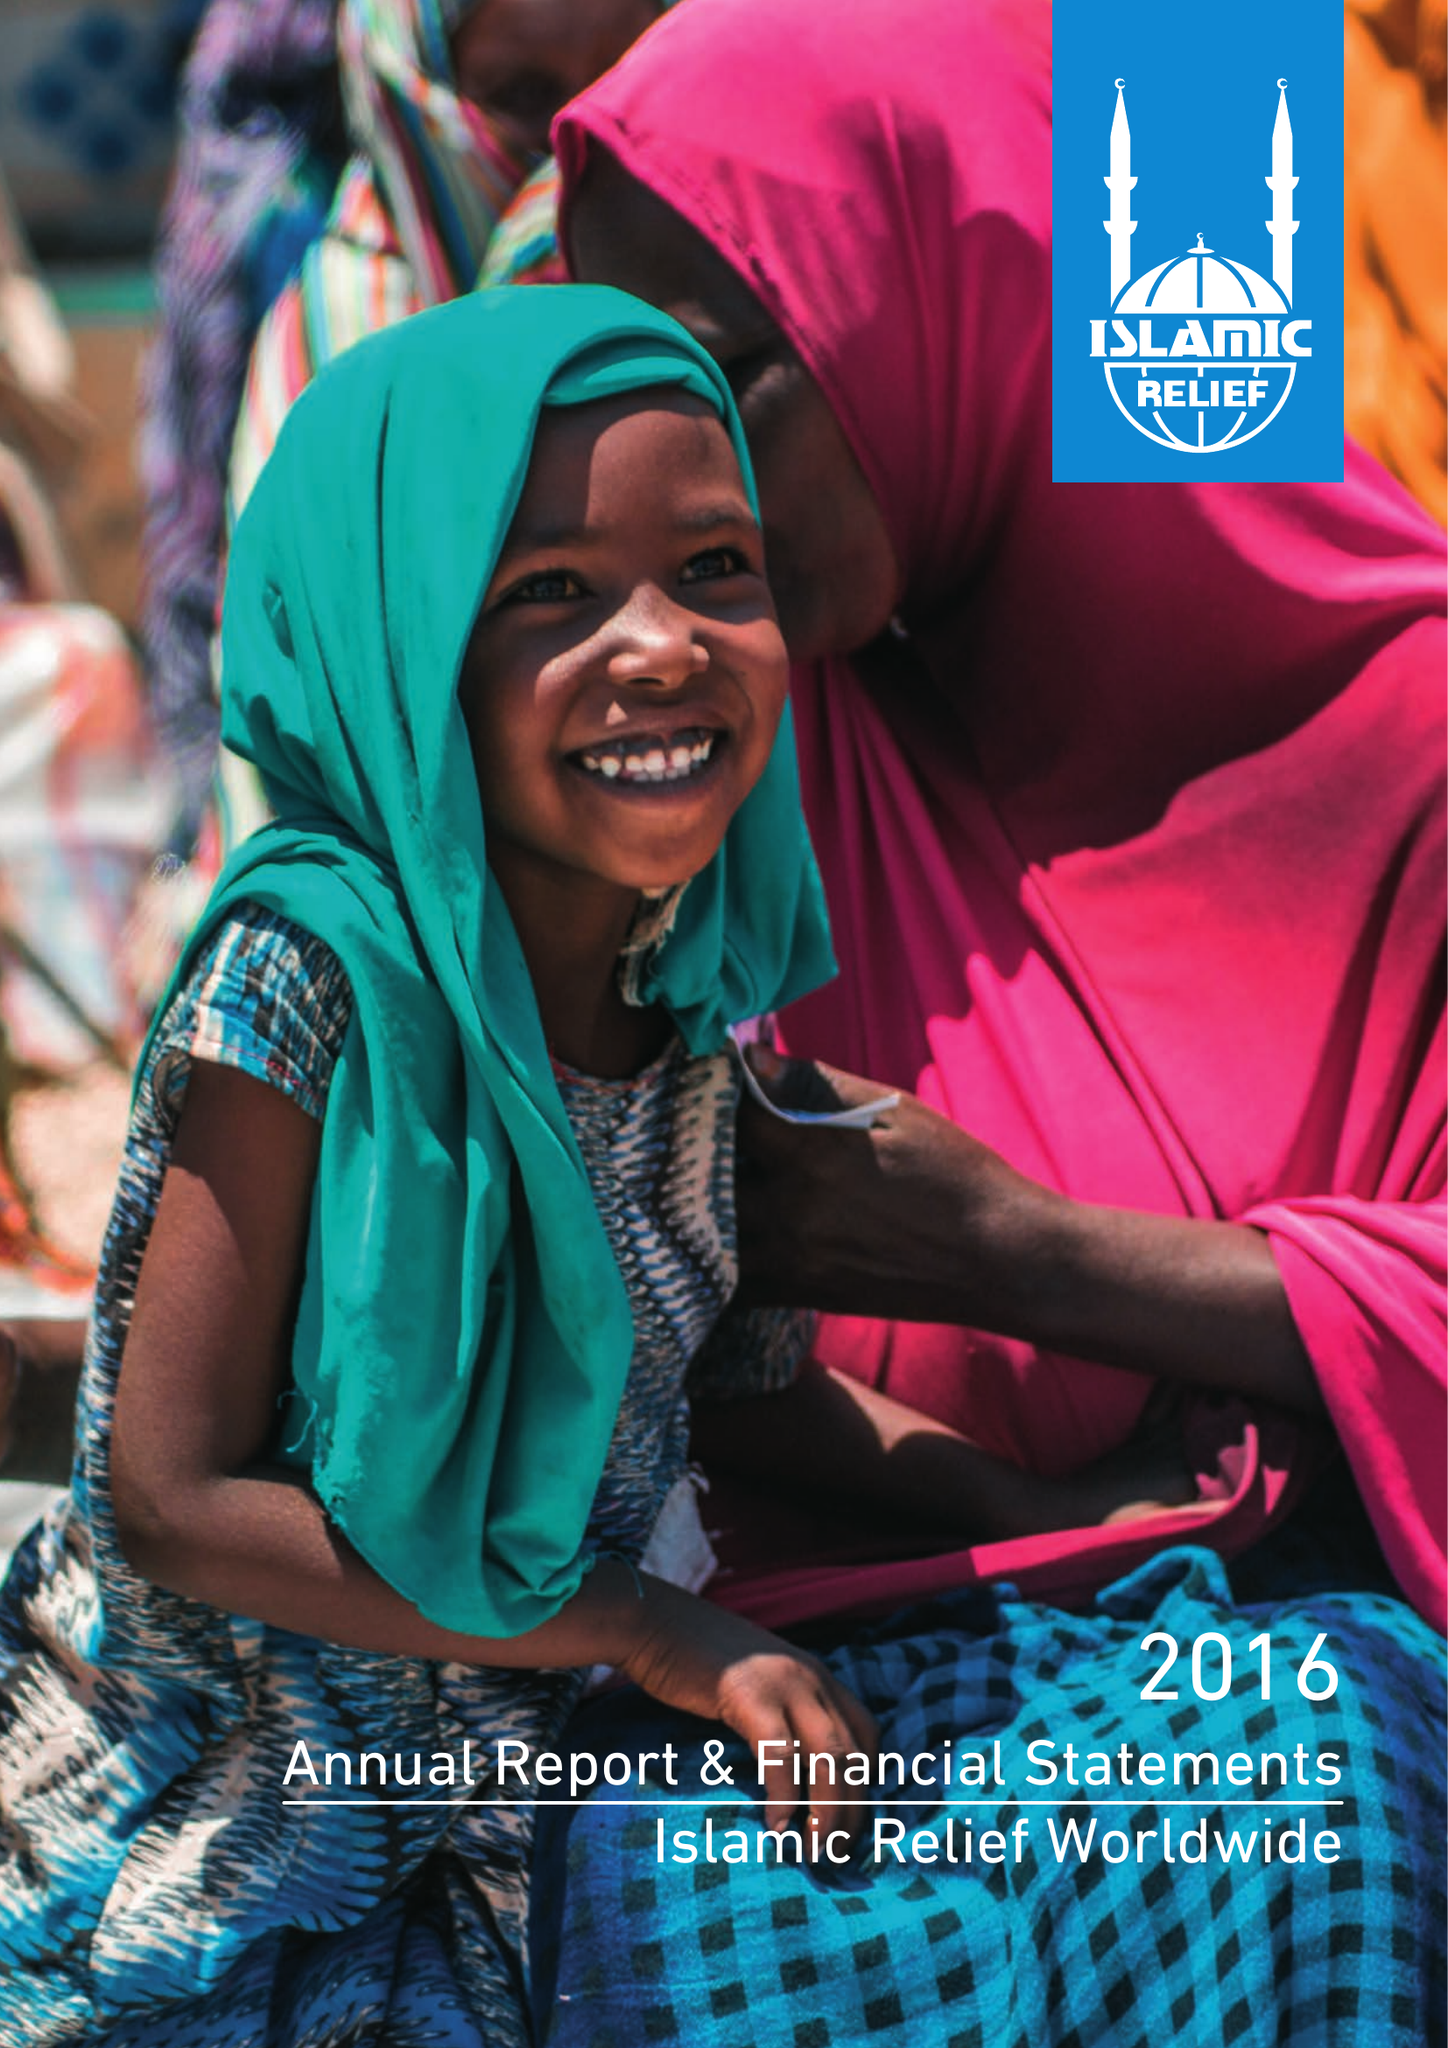What is the value for the spending_annually_in_british_pounds?
Answer the question using a single word or phrase. 112119466.00 